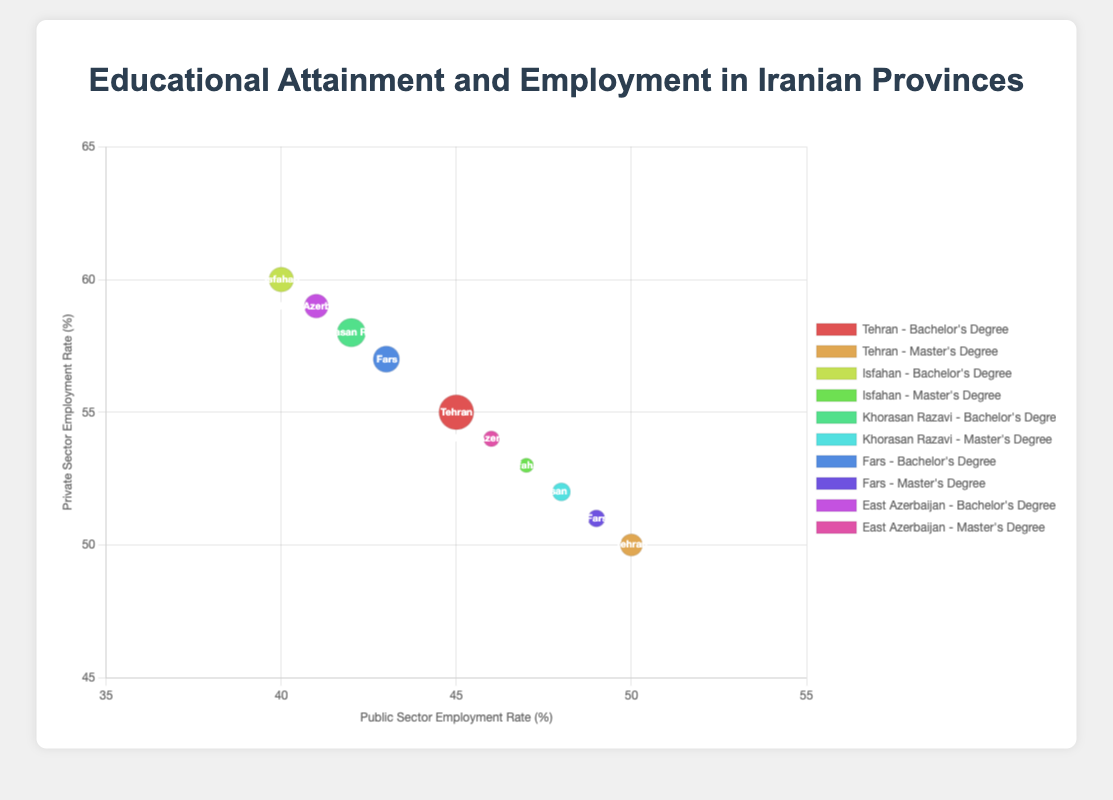What is the employment rate in the private sector for individuals with a Bachelor's degree in Tehran? Locate the bubble corresponding to Tehran with a Bachelor's degree. The y-axis value represents the private sector employment rate, which is 55%.
Answer: 55% Which province has the highest public sector employment rate for individuals with a Master's degree? Compare the public sector employment rates for Master's degrees across all provinces. Tehran has the highest rate at 50%.
Answer: Tehran What is the total population of individuals with a Bachelor's degree across all provinces? Sum the populations of individuals with a Bachelor's degree from all provinces: 3000000 (Tehran) + 1500000 (Isfahan) + 2000000 (Khorasan Razavi) + 1700000 (Fars) + 1400000 (East Azerbaijan) = 9600000.
Answer: 9600000 How does the public sector employment rate for individuals with a Master's degree in Fars compare to that in Isfahan? The public sector employment rate for Master's degrees in Fars is 49%. In Isfahan, it is 47%. Therefore, Fars has a higher rate by 2%.
Answer: Fars by 2% Which province has the largest bubble for individuals with a Bachelor's degree? Identify the bubbles for Bachelor's degrees and compare their sizes. Tehran has the largest bubble, indicating the highest population of 3000000 for that educational attainment level.
Answer: Tehran How many provinces have a higher private sector employment rate than public sector employment rate for individuals with a Bachelor's degree? Compare the public and private sector employment rates for Bachelor's degrees across all provinces. All provinces (Tehran, Isfahan, Khorasan Razavi, Fars, East Azerbaijan) show a higher private sector employment rate. Thus, there are 5 such provinces.
Answer: 5 Is there any province where individuals with a Master's degree have equal employment rates in both the public and private sectors? Examine the employment rates for Master's degrees in each province. Tehran has equal employment rates of 50% in both sectors.
Answer: Tehran Which educational attainment level generally has a higher public sector employment rate within each province? Compare public sector employment rates for both educational levels in each province: Bachelor's and Master's degrees. Master's degrees generally show higher rates in Tehran, Isfahan, Khorasan Razavi, Fars, and East Azerbaijan.
Answer: Master's degree What is the difference in private sector employment rates between Master's and Bachelor's degrees in East Azerbaijan? For East Azerbaijan: Private sector employment rate for Bachelor's is 59%, and for Master's is 54%. The difference is 59% - 54% = 5%.
Answer: 5% Which provinces show an increase in public sector employment rates from Bachelor's to Master's degrees? Compare the public sector employment rates between the two education levels for each province. All provinces (Tehran, Isfahan, Khorasan Razavi, Fars, East Azerbaijan) show an increase in public sector employment for those with a Master's degree.
Answer: All provinces 